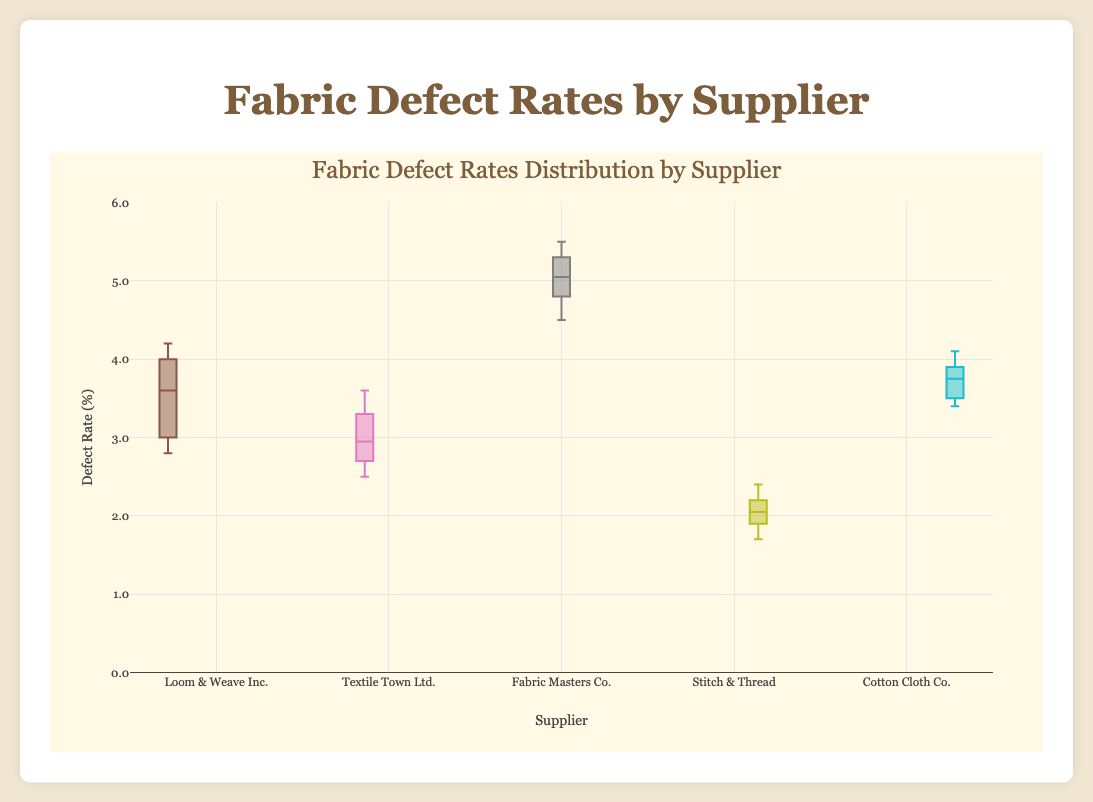What is the range of defect rates for Loom & Weave Inc.? The range is the difference between the highest and lowest values. The highest defect rate for Loom & Weave Inc. is 4.2 and the lowest is 2.8. Thus, the range is 4.2 - 2.8 = 1.4
Answer: 1.4 Which supplier has the lowest median defect rate? The median is the middle value of the dataset when arranged in ascending order. By visual inspection, Stitch & Thread has the lowest median defect rate, as its box plot's median line is at the lowest position among all suppliers
Answer: Stitch & Thread How do the 75th percentiles of Textile Town Ltd. and Cotton Cloth Co. compare? The 75th percentile, or the upper quartile, is the top edge of the box in a box plot. Textile Town Ltd.'s 75th percentile is around 3.3, while Cotton Cloth Co.'s 75th percentile is around 4.0. Therefore, Cotton Cloth Co.'s 75th percentile is higher
Answer: Cotton Cloth Co Which supplier exhibits the highest variability in defect rates? Variability can be observed by the length of the box and whiskers. Fabric Masters Co.'s box plot shows the longest box and whiskers, indicating the highest variability in defect rates
Answer: Fabric Masters Co What is the interquartile range (IQR) for Textile Town Ltd.? The IQR is the difference between the 75th and 25th percentiles. For Textile Town Ltd., the 75th percentile is approximately 3.3 and the 25th percentile is approximately 2.7. Thus, the IQR is 3.3 - 2.7 = 0.6
Answer: 0.6 How does the upper whisker of Loom & Weave Inc. compare to that of Fabric Masters Co.? The upper whisker extends to the maximum value not considered an outlier. For Loom & Weave Inc., it is 4.2, while for Fabric Masters Co., it is 5.5. Therefore, Fabric Masters Co.'s upper whisker is higher
Answer: Fabric Masters Co Which supplier has the smallest range in defect rates? The smallest range is observed by the shortest box and whiskers. Stitch & Thread has the smallest range, with defect rates ranging from 1.7 to 2.4, making the range 0.7
Answer: Stitch & Thread 